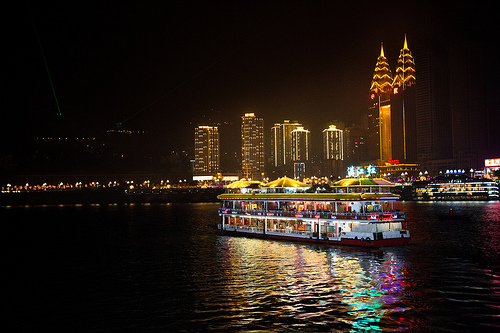Imagine you are on that boat. Describe your experience. As I step onto the boat, I'm greeted by the warm, ambient lighting and the sound of gentle music playing in the background. The air is fresh with a slight breeze coming off the water, creating a perfect evening atmosphere. The city skyline glistens with lights, and the reflections dance on the water's surface. I find a comfortable spot on the upper deck with a panoramic view, and as the boat starts moving, I feel a sense of relaxation and excitement. The staff is attentive, offering a range of delicious foods and drinks. I sip on a glass of wine, chatting with fellow passengers, and take in the sights of iconic landmarks we pass by. It’s a perfect night of leisure and enjoyment. 